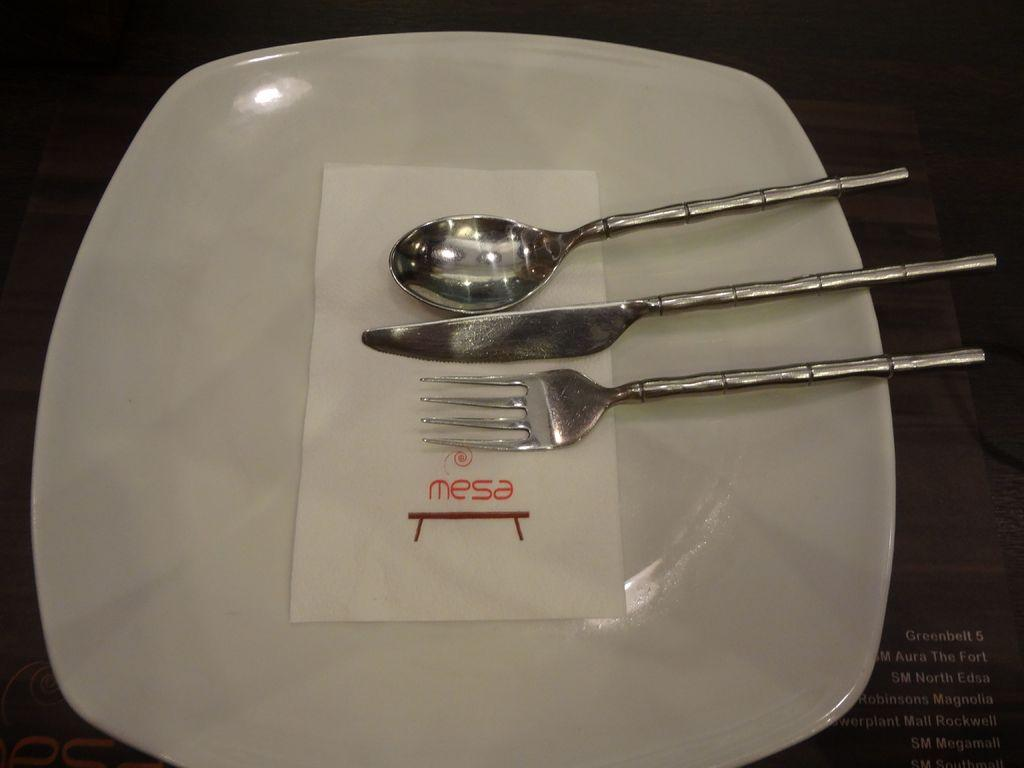What type of utensil is present in the image? There is a spoon, a fork, and a knife in the image. What else can be seen on the plate in the image? There are tissues in the image. What might be used for cutting in the image? There is a knife in the image, which can be used for cutting. What might be used for picking up food in the image? The fork and spoon in the image can be used for picking up food. What type of polish is being applied to the table in the image? There is no polish or table present in the image. What type of prose can be seen written on the plate in the image? There is no prose or writing present on the plate in the image. 